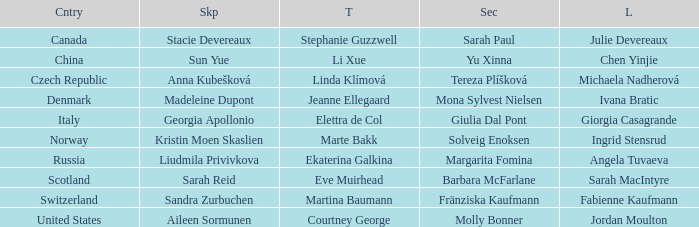What is the second that has jordan moulton as the lead? Molly Bonner. Write the full table. {'header': ['Cntry', 'Skp', 'T', 'Sec', 'L'], 'rows': [['Canada', 'Stacie Devereaux', 'Stephanie Guzzwell', 'Sarah Paul', 'Julie Devereaux'], ['China', 'Sun Yue', 'Li Xue', 'Yu Xinna', 'Chen Yinjie'], ['Czech Republic', 'Anna Kubešková', 'Linda Klímová', 'Tereza Plíšková', 'Michaela Nadherová'], ['Denmark', 'Madeleine Dupont', 'Jeanne Ellegaard', 'Mona Sylvest Nielsen', 'Ivana Bratic'], ['Italy', 'Georgia Apollonio', 'Elettra de Col', 'Giulia Dal Pont', 'Giorgia Casagrande'], ['Norway', 'Kristin Moen Skaslien', 'Marte Bakk', 'Solveig Enoksen', 'Ingrid Stensrud'], ['Russia', 'Liudmila Privivkova', 'Ekaterina Galkina', 'Margarita Fomina', 'Angela Tuvaeva'], ['Scotland', 'Sarah Reid', 'Eve Muirhead', 'Barbara McFarlane', 'Sarah MacIntyre'], ['Switzerland', 'Sandra Zurbuchen', 'Martina Baumann', 'Fränziska Kaufmann', 'Fabienne Kaufmann'], ['United States', 'Aileen Sormunen', 'Courtney George', 'Molly Bonner', 'Jordan Moulton']]} 